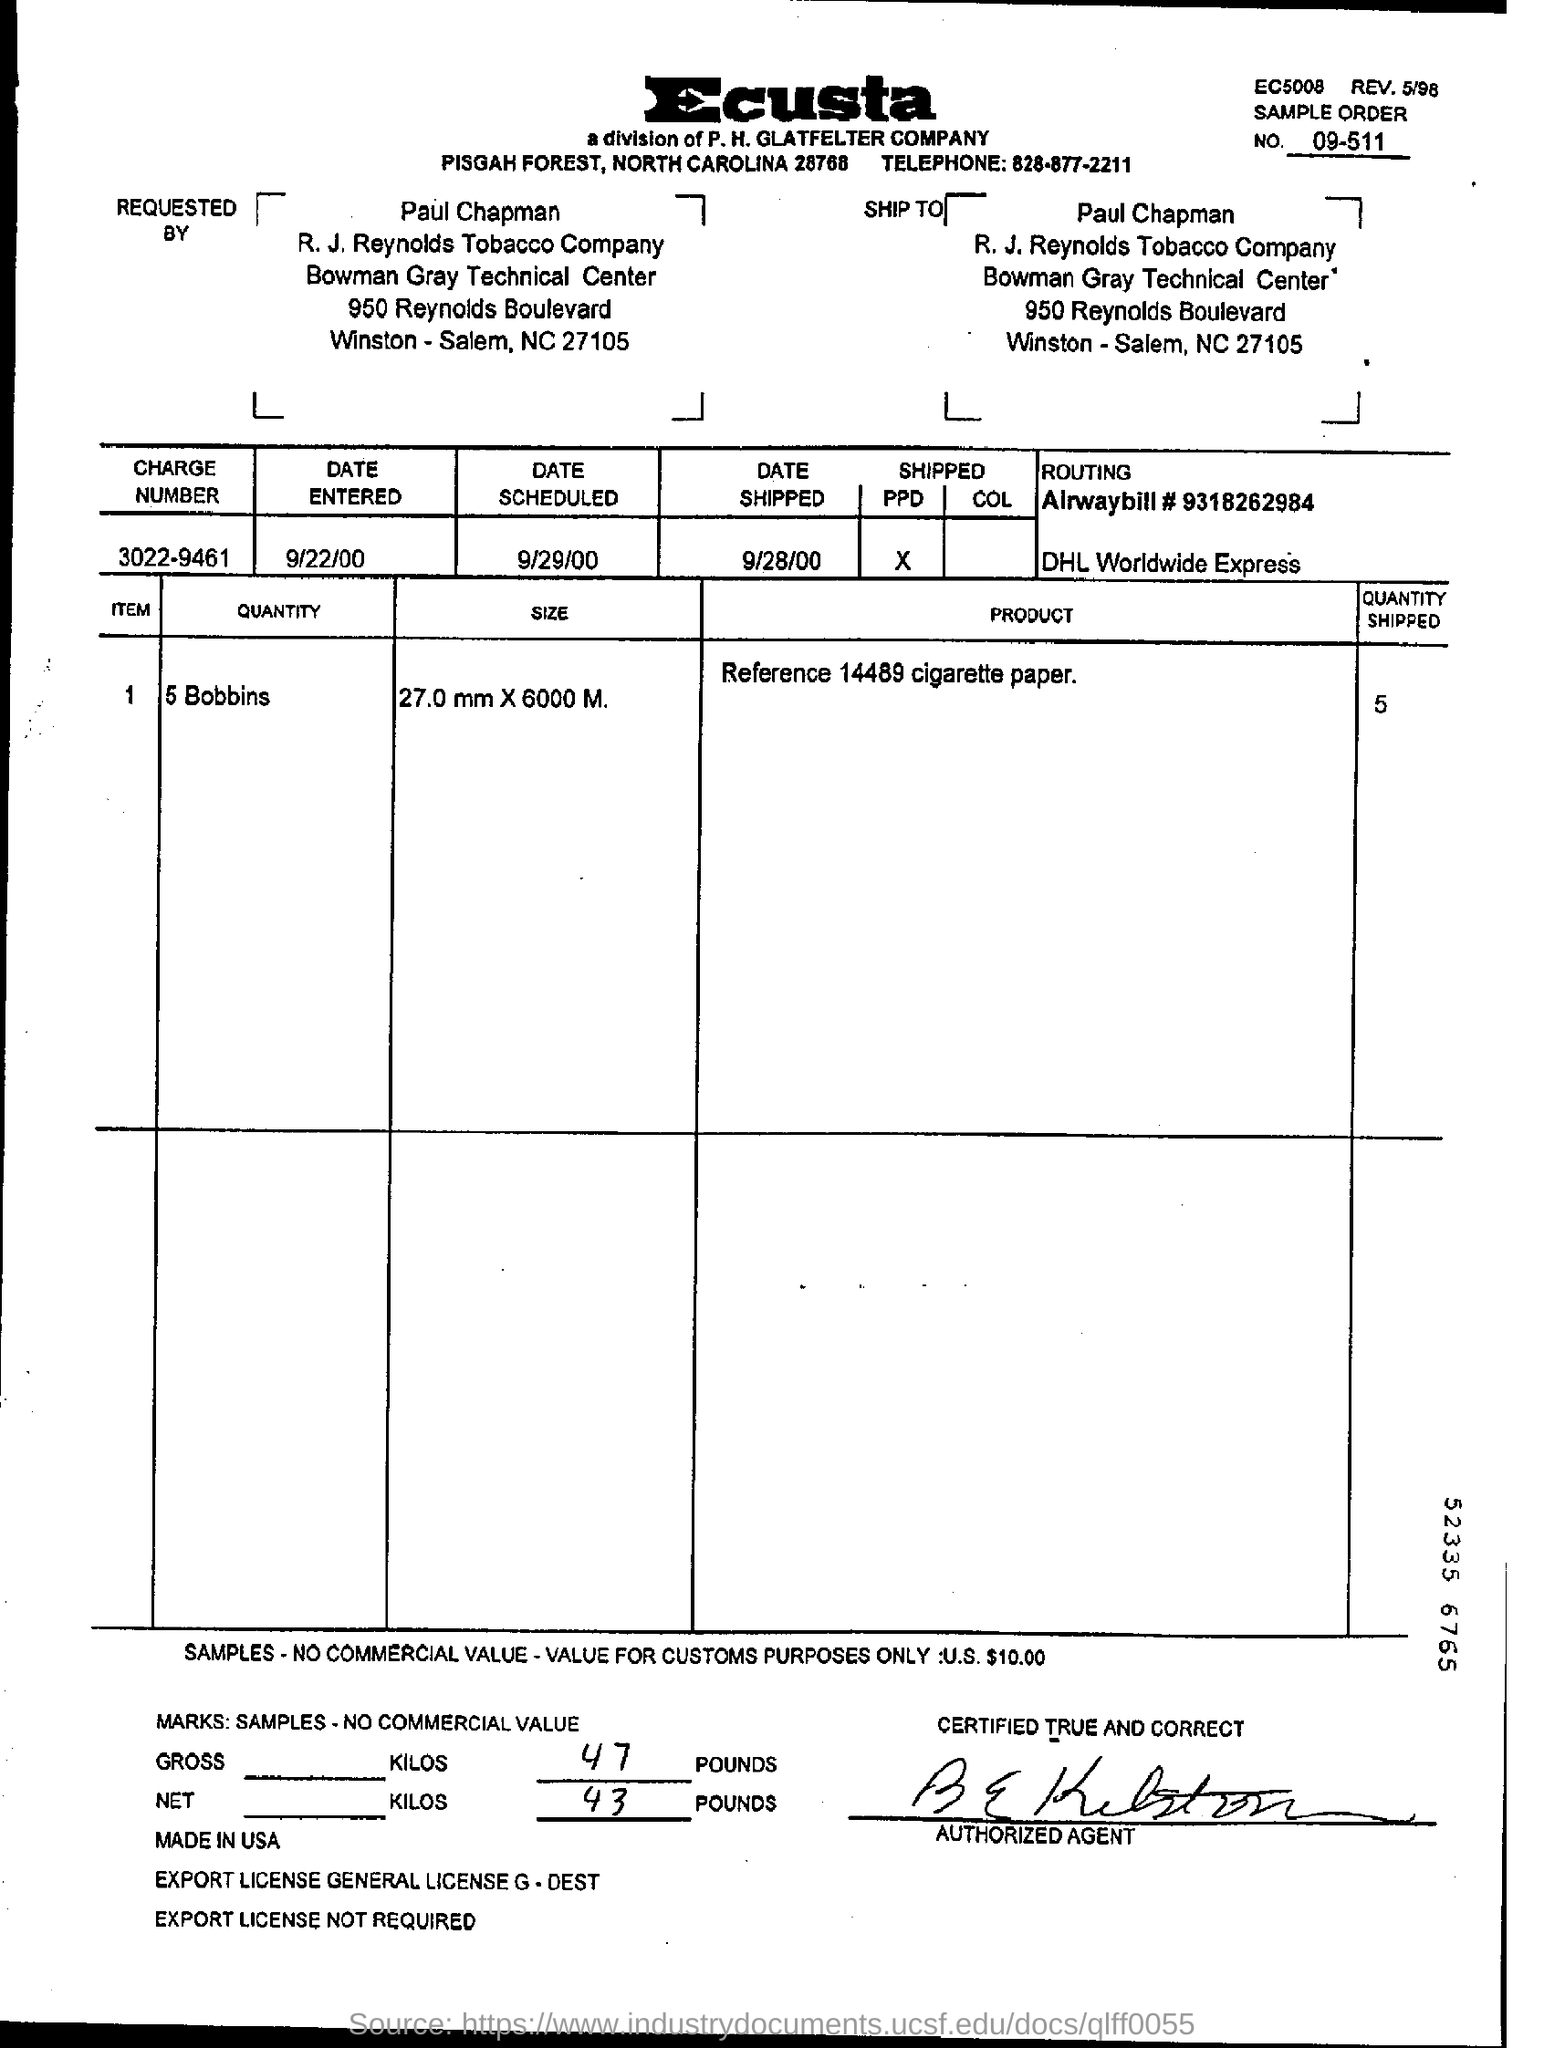Identify some key points in this picture. The quantity shipped is 5.. The product mentioned in the document is cigarette paper, as indicated by Reference 14489. The sample order number mentioned in the document is 09-511. The requester of this order is identified as Paul Chapman. The charge number given is 3022-9461. 